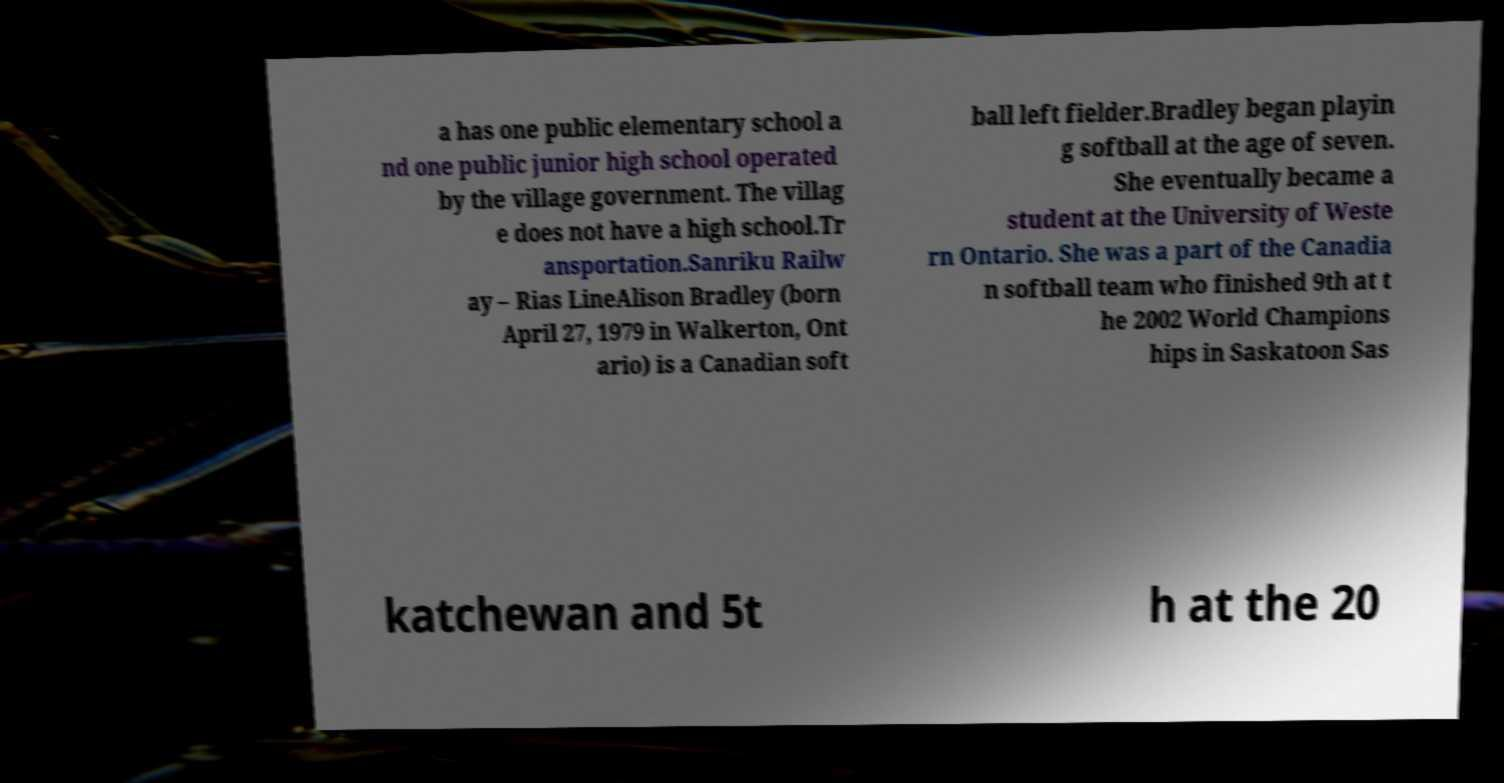What messages or text are displayed in this image? I need them in a readable, typed format. a has one public elementary school a nd one public junior high school operated by the village government. The villag e does not have a high school.Tr ansportation.Sanriku Railw ay – Rias LineAlison Bradley (born April 27, 1979 in Walkerton, Ont ario) is a Canadian soft ball left fielder.Bradley began playin g softball at the age of seven. She eventually became a student at the University of Weste rn Ontario. She was a part of the Canadia n softball team who finished 9th at t he 2002 World Champions hips in Saskatoon Sas katchewan and 5t h at the 20 